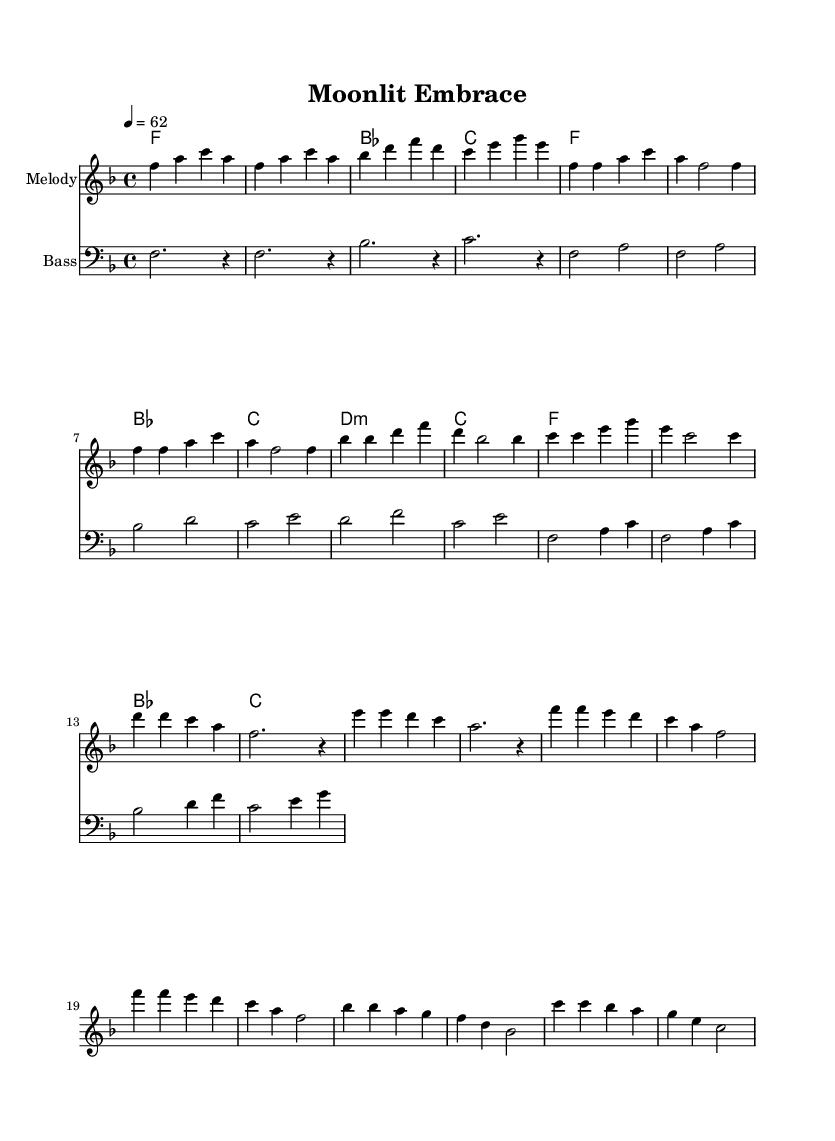What is the key signature of this music? The key signature is indicated by the notes in the scale. In this music, there are one flat (B flat), which indicates that the music is in F major.
Answer: F major What is the time signature of this music? The time signature is shown at the beginning of the staff. It displays "4/4", which means there are 4 beats in each measure and the quarter note gets one beat.
Answer: 4/4 What is the tempo marking for this music? The tempo is specified at the beginning of the piece with "4 = 62", meaning there should be 62 beats per minute. This is a slow tempo, suitable for a ballad.
Answer: 62 How many measures are there in the chorus section? By counting the measures labeled "Chorus" in the sheet music, we see there are 4 distinct measures within this section.
Answer: 4 What type of chords are used in the Pre-Chorus section? The chords in the Pre-Chorus section are labeled with specific quality indicators. In this case, there is a minor chord (D minor) followed by a major chord (C major). This is typical in soulful music to convey emotion.
Answer: D minor, C major What is the range of the highest note in this composition? The melody line reaches its highest note at f' (F in the fourth octave), which is shown in the melody staff. This is the peak note in the chorus part.
Answer: f prime Which section is primarily built around a repetitive harmonic pattern? When examining the structure of the music, the Verse section prominently repeats its harmonic sequence, which provides a stable foundation for expressions in dance.
Answer: Verse 